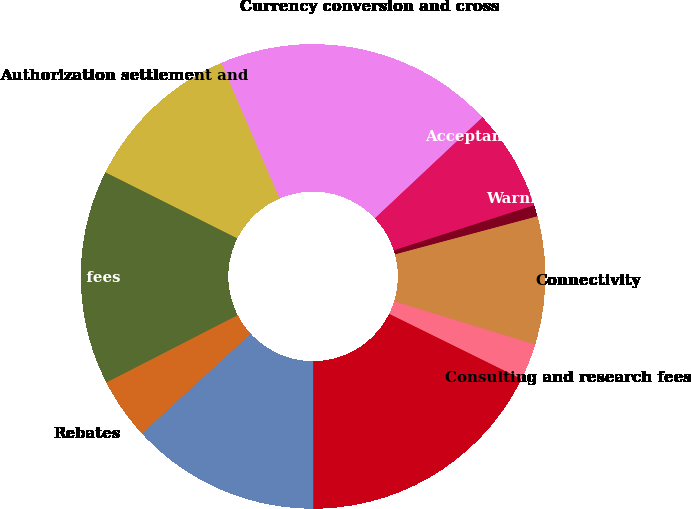<chart> <loc_0><loc_0><loc_500><loc_500><pie_chart><fcel>Authorization settlement and<fcel>Currency conversion and cross<fcel>Acceptance development fees<fcel>Warning bulletin fees<fcel>Connectivity<fcel>Consulting and research fees<fcel>Other operations fees<fcel>Gross operations fees<fcel>Rebates<fcel>Net operations fees<nl><fcel>11.16%<fcel>19.45%<fcel>7.05%<fcel>0.79%<fcel>8.91%<fcel>2.54%<fcel>17.7%<fcel>13.19%<fcel>4.28%<fcel>14.93%<nl></chart> 